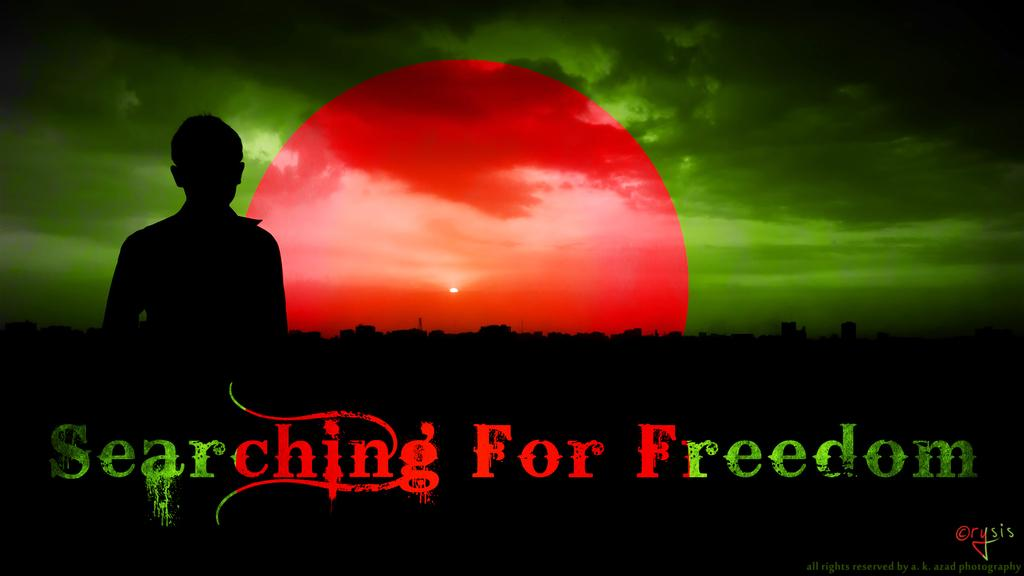Provide a one-sentence caption for the provided image. Screen showing a shadow in front of a red moon that says Searching for Freedom. 